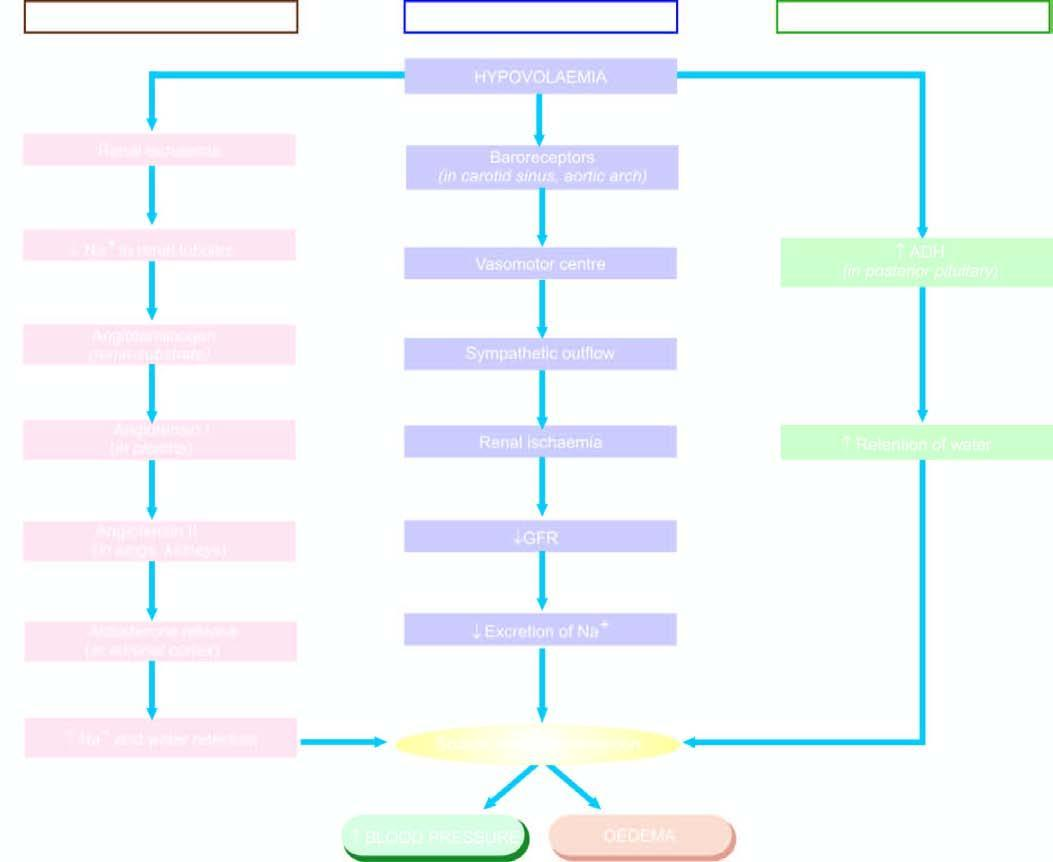re layers of squamous epithelium involved in oedema by sodium and water retention?
Answer the question using a single word or phrase. No 